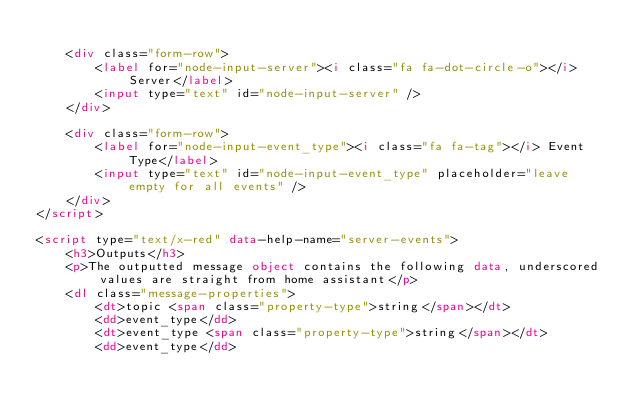<code> <loc_0><loc_0><loc_500><loc_500><_HTML_>
    <div class="form-row">
        <label for="node-input-server"><i class="fa fa-dot-circle-o"></i> Server</label>
        <input type="text" id="node-input-server" />
    </div>

    <div class="form-row">
        <label for="node-input-event_type"><i class="fa fa-tag"></i> Event Type</label>
        <input type="text" id="node-input-event_type" placeholder="leave empty for all events" />
    </div>
</script>

<script type="text/x-red" data-help-name="server-events">
    <h3>Outputs</h3>
    <p>The outputted message object contains the following data, underscored values are straight from home assistant</p>
    <dl class="message-properties">
        <dt>topic <span class="property-type">string</span></dt>
        <dd>event_type</dd>
        <dt>event_type <span class="property-type">string</span></dt>
        <dd>event_type</dd></code> 